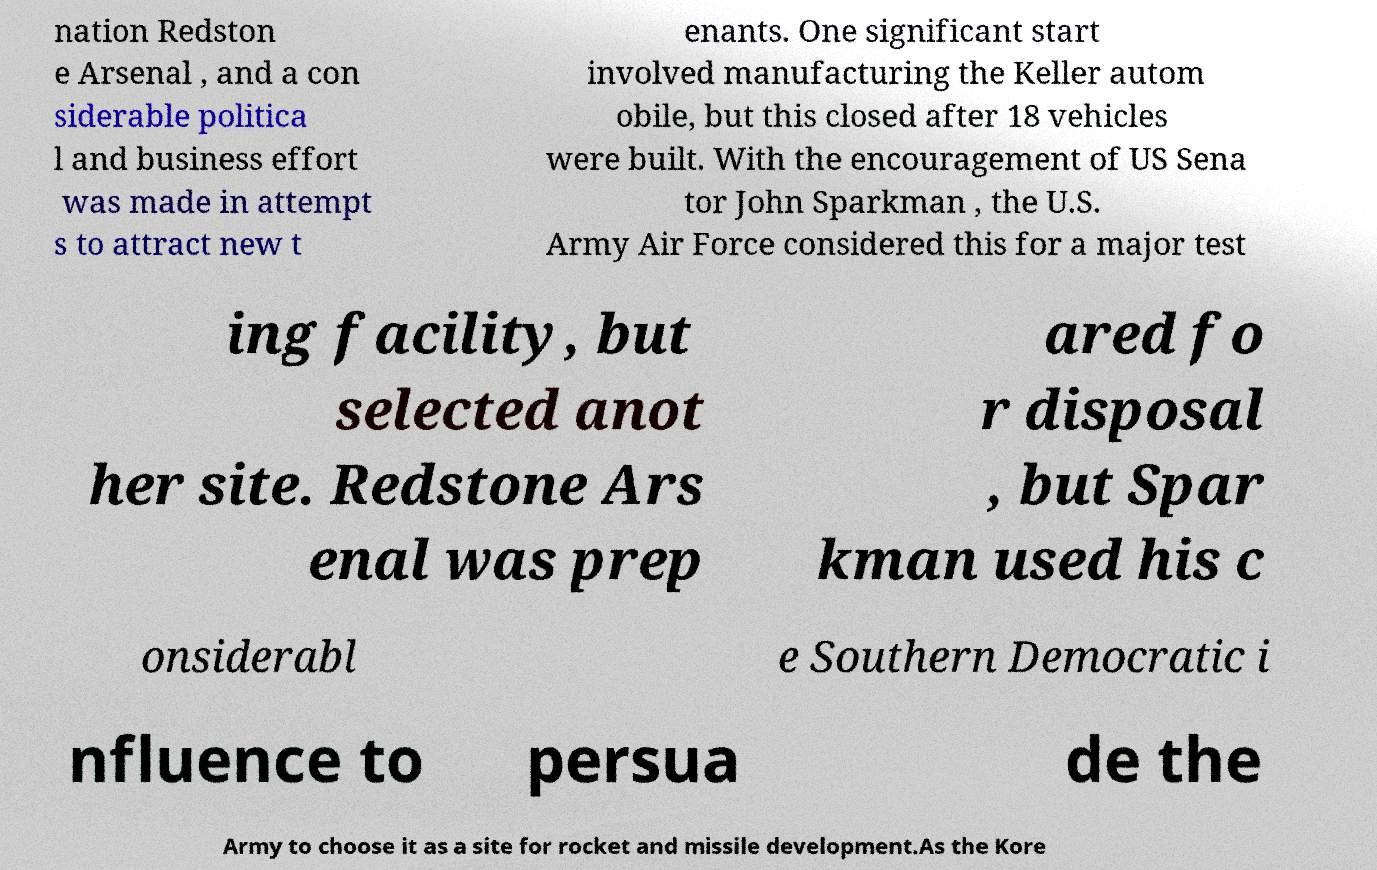What messages or text are displayed in this image? I need them in a readable, typed format. nation Redston e Arsenal , and a con siderable politica l and business effort was made in attempt s to attract new t enants. One significant start involved manufacturing the Keller autom obile, but this closed after 18 vehicles were built. With the encouragement of US Sena tor John Sparkman , the U.S. Army Air Force considered this for a major test ing facility, but selected anot her site. Redstone Ars enal was prep ared fo r disposal , but Spar kman used his c onsiderabl e Southern Democratic i nfluence to persua de the Army to choose it as a site for rocket and missile development.As the Kore 